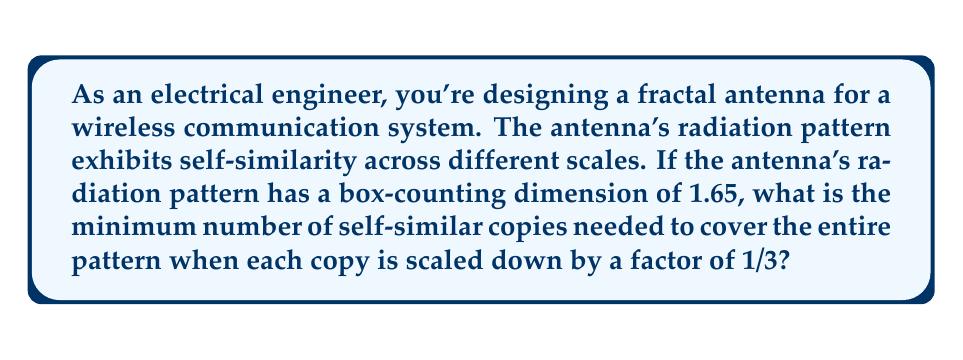Could you help me with this problem? Let's approach this step-by-step:

1) The fractal dimension $D$ is related to the number of self-similar copies $N$ and the scaling factor $r$ by the equation:

   $$D = \frac{\log N}{\log(1/r)}$$

2) We're given that $D = 1.65$ and $r = 1/3$. We need to solve for $N$.

3) Substituting the known values:

   $$1.65 = \frac{\log N}{\log(1/(1/3))} = \frac{\log N}{\log 3}$$

4) Rearranging the equation:

   $$\log N = 1.65 \log 3$$

5) Taking the exponential of both sides:

   $$N = e^{1.65 \log 3} = 3^{1.65}$$

6) Calculating this value:

   $$N \approx 9.6825$$

7) Since we need the minimum number of copies, and $N$ must be an integer, we round up to the nearest whole number.
Answer: 10 